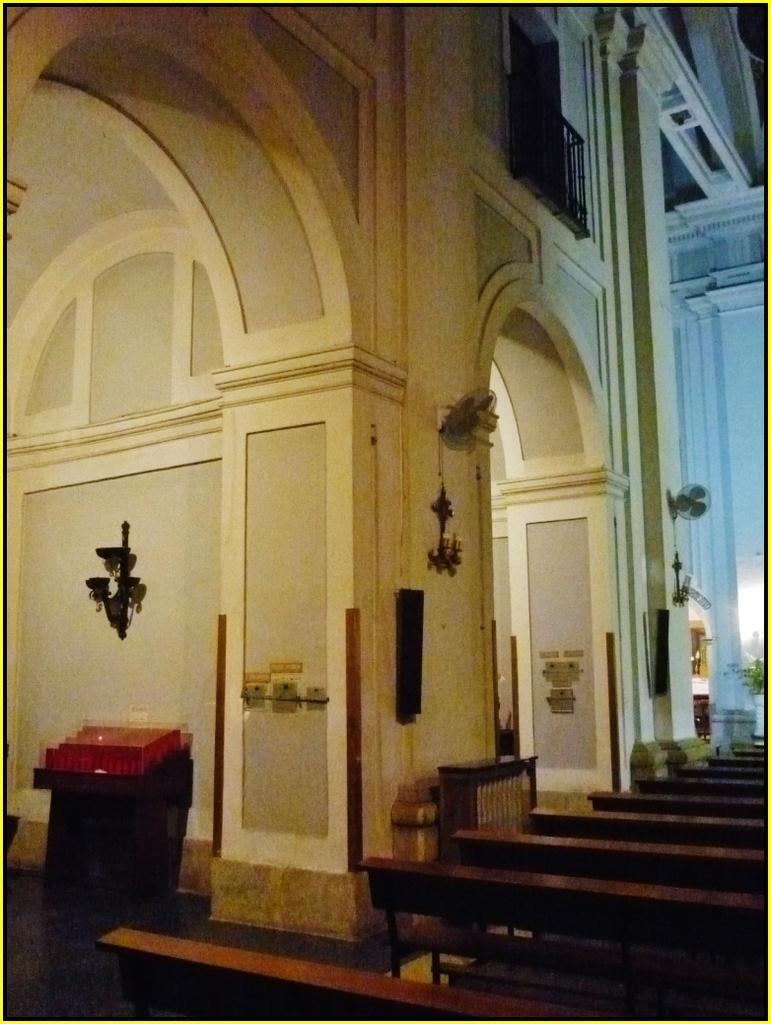Could you give a brief overview of what you see in this image? It is an inside view of a building. Here we can see walls, decorative objects, benches, table fans, railing and few things. 